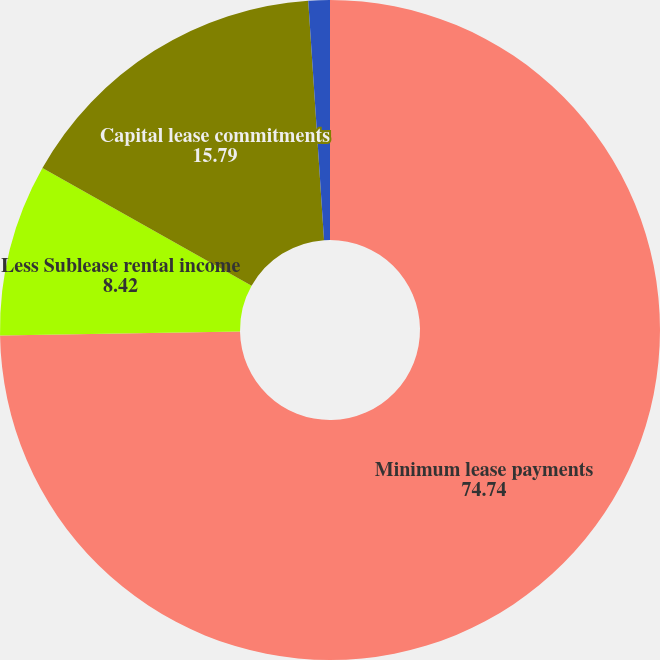<chart> <loc_0><loc_0><loc_500><loc_500><pie_chart><fcel>Minimum lease payments<fcel>Less Sublease rental income<fcel>Capital lease commitments<fcel>Less Interest payments<nl><fcel>74.74%<fcel>8.42%<fcel>15.79%<fcel>1.05%<nl></chart> 